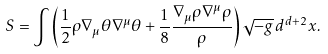<formula> <loc_0><loc_0><loc_500><loc_500>S = \int \left ( \frac { 1 } { 2 } \rho \nabla _ { \mu } \theta \nabla ^ { \mu } \theta + \frac { 1 } { 8 } \frac { \nabla _ { \mu } \rho \nabla ^ { \mu } \rho } { \rho } \right ) \sqrt { - g } \, d ^ { d + 2 } x .</formula> 